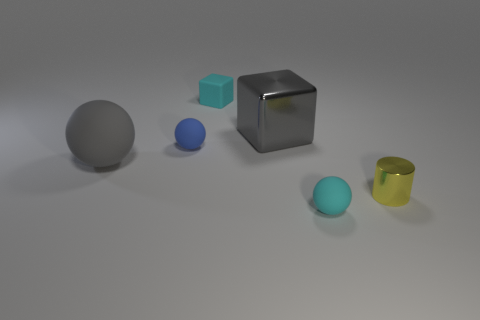There is a block that is the same color as the large rubber ball; what is its material?
Your response must be concise. Metal. What is the shape of the gray metal thing that is the same size as the gray sphere?
Keep it short and to the point. Cube. How many other objects are there of the same color as the large metallic block?
Your answer should be very brief. 1. What number of other things are there of the same material as the small blue sphere
Your answer should be very brief. 3. There is a gray rubber thing; is its size the same as the metal thing that is to the left of the yellow cylinder?
Your answer should be compact. Yes. What is the color of the metal cylinder?
Make the answer very short. Yellow. What shape is the large gray thing that is to the left of the tiny rubber object behind the tiny matte sphere that is behind the cyan ball?
Your answer should be very brief. Sphere. There is a tiny thing that is right of the matte thing in front of the metallic cylinder; what is it made of?
Provide a short and direct response. Metal. What shape is the cyan object that is made of the same material as the tiny block?
Your answer should be very brief. Sphere. Is there anything else that is the same shape as the gray matte object?
Give a very brief answer. Yes. 